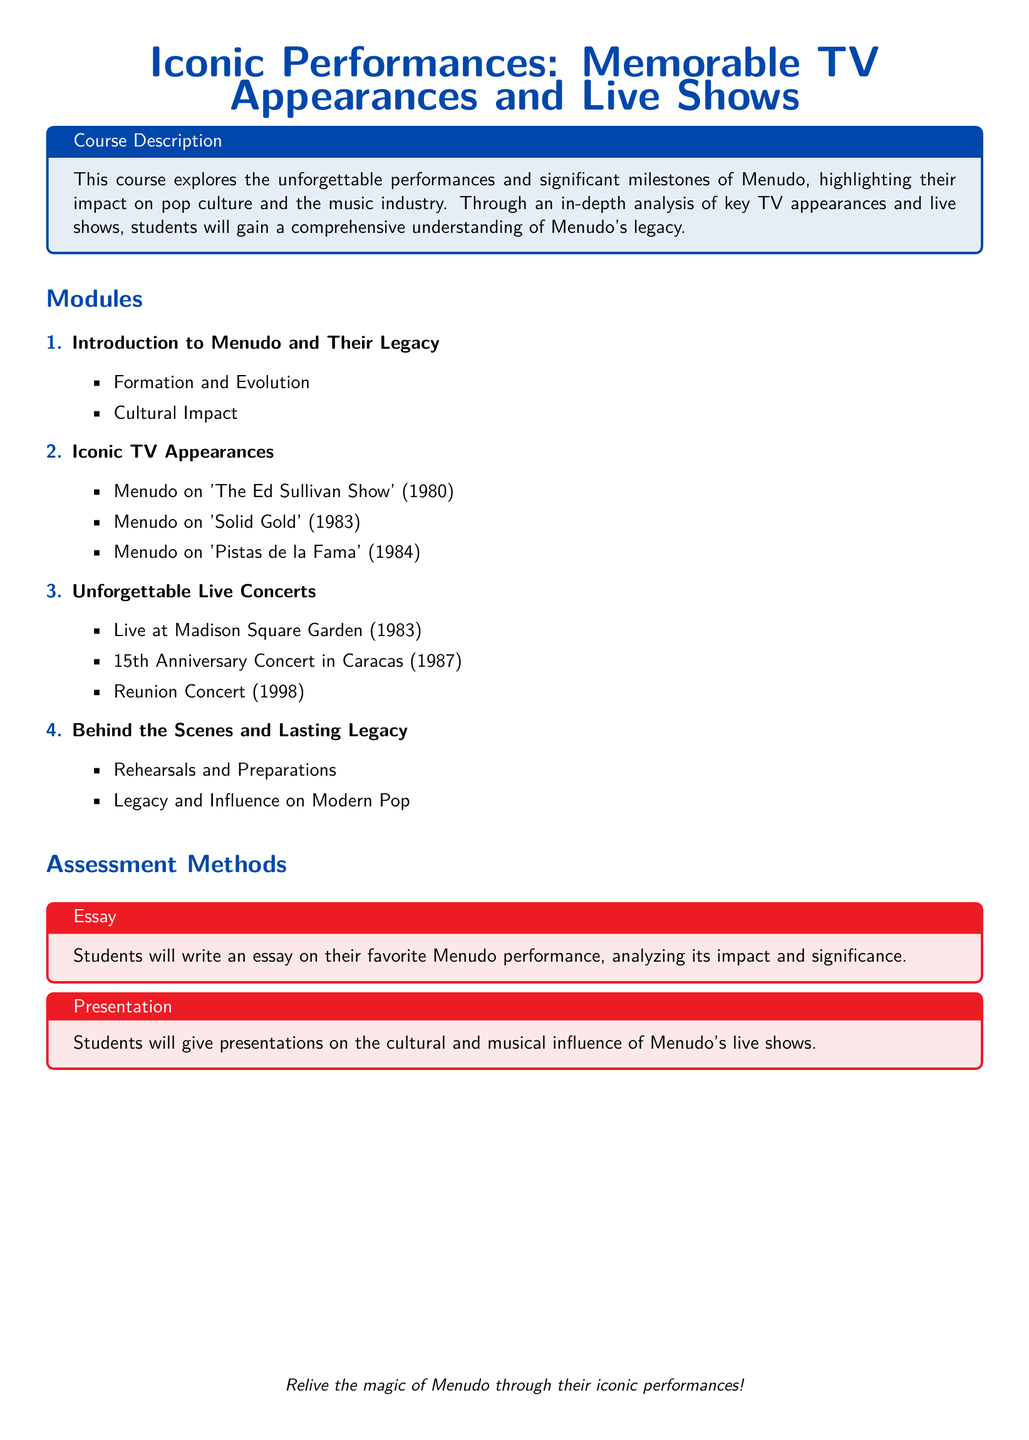What is the title of the course? The title of the course is mentioned at the top of the document.
Answer: Iconic Performances: Memorable TV Appearances and Live Shows In which year did Menudo appear on 'The Ed Sullivan Show'? The year of this TV appearance is specified in the modules section.
Answer: 1980 What was one of the live concert locations mentioned? The syllabus lists live concert locations in the unforgettable live concerts module.
Answer: Madison Square Garden How many modules are listed in the syllabus? The total number of numbered items in the modules section indicates this information.
Answer: 4 What type of assessment involves writing an essay? The type of assessment is indicated in the assessment methods section.
Answer: Essay Which concert is noted as the 15th Anniversary Concert? This concert name is found in the unforgettable live concerts module.
Answer: 15th Anniversary Concert in Caracas What color is used for section titles in the document? The document specifies the color used for section titles.
Answer: Menudo blue What is the focus of the second module? The focus is described in the module headings; this module is specifically about TV appearances.
Answer: Iconic TV Appearances 